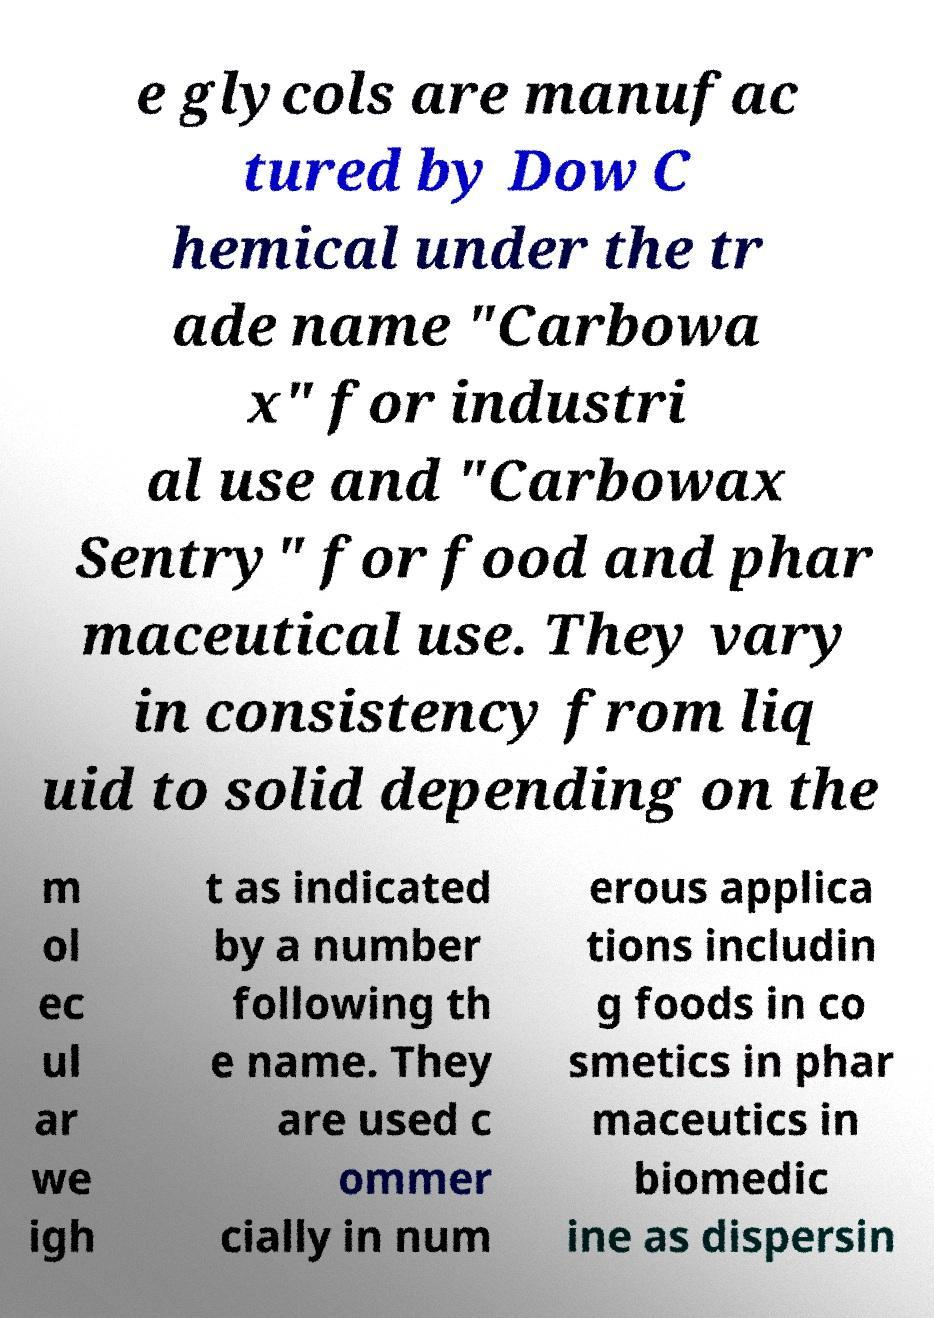Could you assist in decoding the text presented in this image and type it out clearly? e glycols are manufac tured by Dow C hemical under the tr ade name "Carbowa x" for industri al use and "Carbowax Sentry" for food and phar maceutical use. They vary in consistency from liq uid to solid depending on the m ol ec ul ar we igh t as indicated by a number following th e name. They are used c ommer cially in num erous applica tions includin g foods in co smetics in phar maceutics in biomedic ine as dispersin 